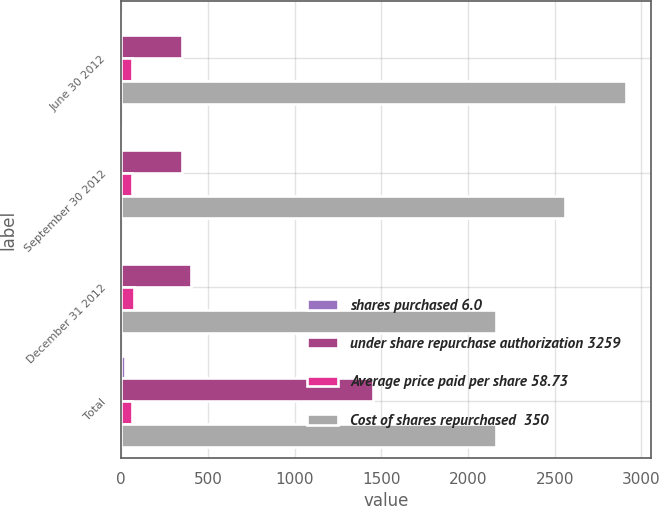<chart> <loc_0><loc_0><loc_500><loc_500><stacked_bar_chart><ecel><fcel>June 30 2012<fcel>September 30 2012<fcel>December 31 2012<fcel>Total<nl><fcel>shares purchased 6.0<fcel>5.6<fcel>5.4<fcel>5.4<fcel>22.4<nl><fcel>under share repurchase authorization 3259<fcel>350<fcel>350<fcel>400<fcel>1450<nl><fcel>Average price paid per share 58.73<fcel>62.4<fcel>65<fcel>73<fcel>64.64<nl><fcel>Cost of shares repurchased  350<fcel>2909<fcel>2559<fcel>2159<fcel>2159<nl></chart> 